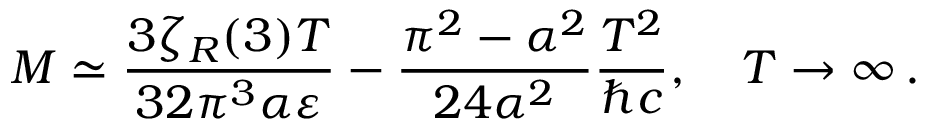Convert formula to latex. <formula><loc_0><loc_0><loc_500><loc_500>M \simeq \frac { 3 \zeta _ { R } ( 3 ) T } { 3 2 \pi ^ { 3 } \alpha \varepsilon } - \frac { \pi ^ { 2 } - \alpha ^ { 2 } } { 2 4 \alpha ^ { 2 } } \frac { T ^ { 2 } } { \hbar { c } } , \quad T \to \infty \, { . }</formula> 